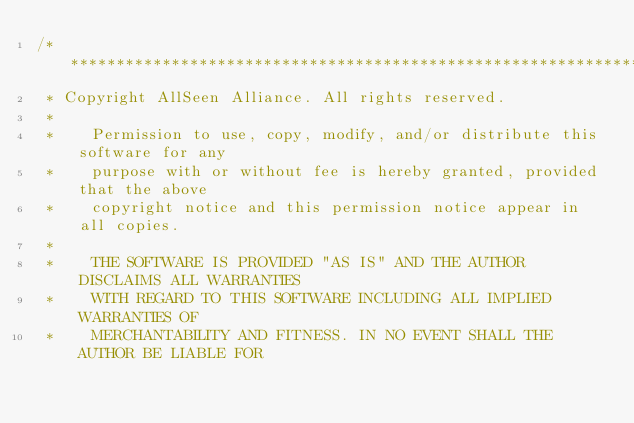<code> <loc_0><loc_0><loc_500><loc_500><_ObjectiveC_>/******************************************************************************
 * Copyright AllSeen Alliance. All rights reserved.
 *
 *    Permission to use, copy, modify, and/or distribute this software for any
 *    purpose with or without fee is hereby granted, provided that the above
 *    copyright notice and this permission notice appear in all copies.
 *
 *    THE SOFTWARE IS PROVIDED "AS IS" AND THE AUTHOR DISCLAIMS ALL WARRANTIES
 *    WITH REGARD TO THIS SOFTWARE INCLUDING ALL IMPLIED WARRANTIES OF
 *    MERCHANTABILITY AND FITNESS. IN NO EVENT SHALL THE AUTHOR BE LIABLE FOR</code> 